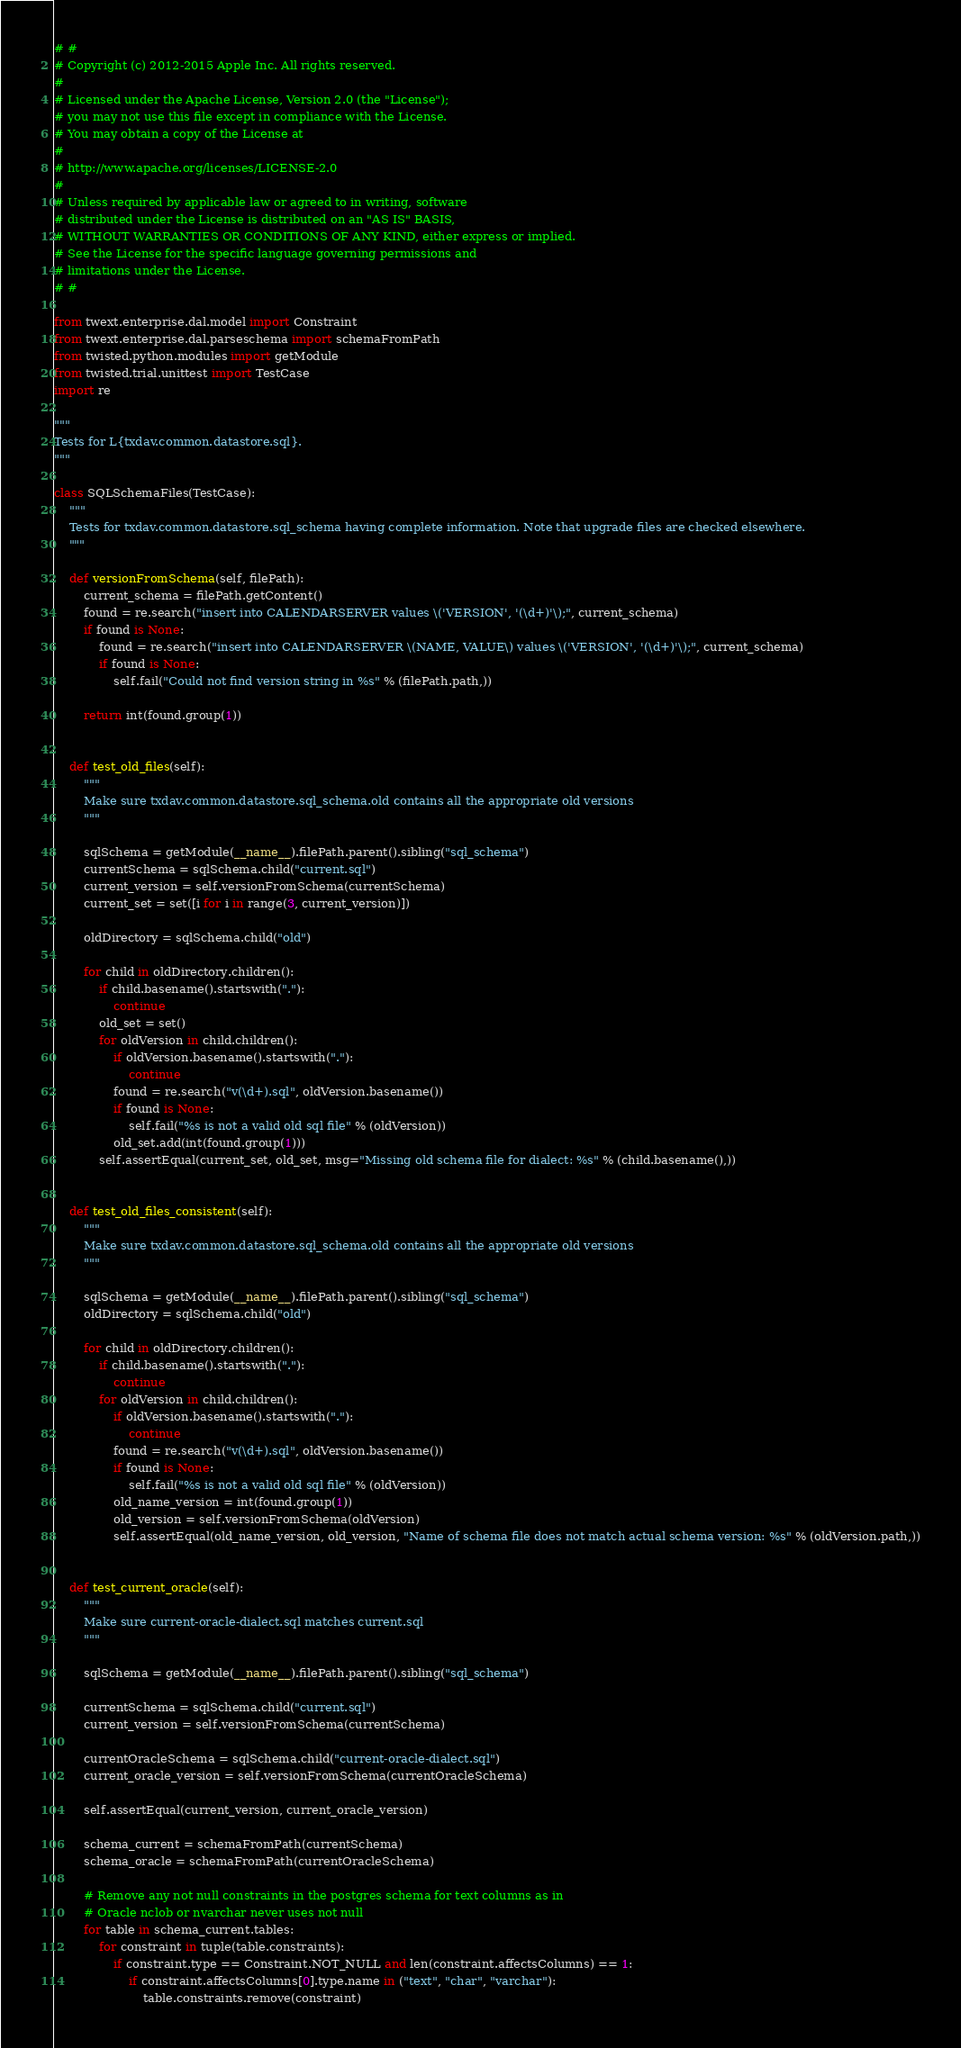<code> <loc_0><loc_0><loc_500><loc_500><_Python_># #
# Copyright (c) 2012-2015 Apple Inc. All rights reserved.
#
# Licensed under the Apache License, Version 2.0 (the "License");
# you may not use this file except in compliance with the License.
# You may obtain a copy of the License at
#
# http://www.apache.org/licenses/LICENSE-2.0
#
# Unless required by applicable law or agreed to in writing, software
# distributed under the License is distributed on an "AS IS" BASIS,
# WITHOUT WARRANTIES OR CONDITIONS OF ANY KIND, either express or implied.
# See the License for the specific language governing permissions and
# limitations under the License.
# #

from twext.enterprise.dal.model import Constraint
from twext.enterprise.dal.parseschema import schemaFromPath
from twisted.python.modules import getModule
from twisted.trial.unittest import TestCase
import re

"""
Tests for L{txdav.common.datastore.sql}.
"""

class SQLSchemaFiles(TestCase):
    """
    Tests for txdav.common.datastore.sql_schema having complete information. Note that upgrade files are checked elsewhere.
    """

    def versionFromSchema(self, filePath):
        current_schema = filePath.getContent()
        found = re.search("insert into CALENDARSERVER values \('VERSION', '(\d+)'\);", current_schema)
        if found is None:
            found = re.search("insert into CALENDARSERVER \(NAME, VALUE\) values \('VERSION', '(\d+)'\);", current_schema)
            if found is None:
                self.fail("Could not find version string in %s" % (filePath.path,))

        return int(found.group(1))


    def test_old_files(self):
        """
        Make sure txdav.common.datastore.sql_schema.old contains all the appropriate old versions
        """

        sqlSchema = getModule(__name__).filePath.parent().sibling("sql_schema")
        currentSchema = sqlSchema.child("current.sql")
        current_version = self.versionFromSchema(currentSchema)
        current_set = set([i for i in range(3, current_version)])

        oldDirectory = sqlSchema.child("old")

        for child in oldDirectory.children():
            if child.basename().startswith("."):
                continue
            old_set = set()
            for oldVersion in child.children():
                if oldVersion.basename().startswith("."):
                    continue
                found = re.search("v(\d+).sql", oldVersion.basename())
                if found is None:
                    self.fail("%s is not a valid old sql file" % (oldVersion))
                old_set.add(int(found.group(1)))
            self.assertEqual(current_set, old_set, msg="Missing old schema file for dialect: %s" % (child.basename(),))


    def test_old_files_consistent(self):
        """
        Make sure txdav.common.datastore.sql_schema.old contains all the appropriate old versions
        """

        sqlSchema = getModule(__name__).filePath.parent().sibling("sql_schema")
        oldDirectory = sqlSchema.child("old")

        for child in oldDirectory.children():
            if child.basename().startswith("."):
                continue
            for oldVersion in child.children():
                if oldVersion.basename().startswith("."):
                    continue
                found = re.search("v(\d+).sql", oldVersion.basename())
                if found is None:
                    self.fail("%s is not a valid old sql file" % (oldVersion))
                old_name_version = int(found.group(1))
                old_version = self.versionFromSchema(oldVersion)
                self.assertEqual(old_name_version, old_version, "Name of schema file does not match actual schema version: %s" % (oldVersion.path,))


    def test_current_oracle(self):
        """
        Make sure current-oracle-dialect.sql matches current.sql
        """

        sqlSchema = getModule(__name__).filePath.parent().sibling("sql_schema")

        currentSchema = sqlSchema.child("current.sql")
        current_version = self.versionFromSchema(currentSchema)

        currentOracleSchema = sqlSchema.child("current-oracle-dialect.sql")
        current_oracle_version = self.versionFromSchema(currentOracleSchema)

        self.assertEqual(current_version, current_oracle_version)

        schema_current = schemaFromPath(currentSchema)
        schema_oracle = schemaFromPath(currentOracleSchema)

        # Remove any not null constraints in the postgres schema for text columns as in
        # Oracle nclob or nvarchar never uses not null
        for table in schema_current.tables:
            for constraint in tuple(table.constraints):
                if constraint.type == Constraint.NOT_NULL and len(constraint.affectsColumns) == 1:
                    if constraint.affectsColumns[0].type.name in ("text", "char", "varchar"):
                        table.constraints.remove(constraint)
</code> 